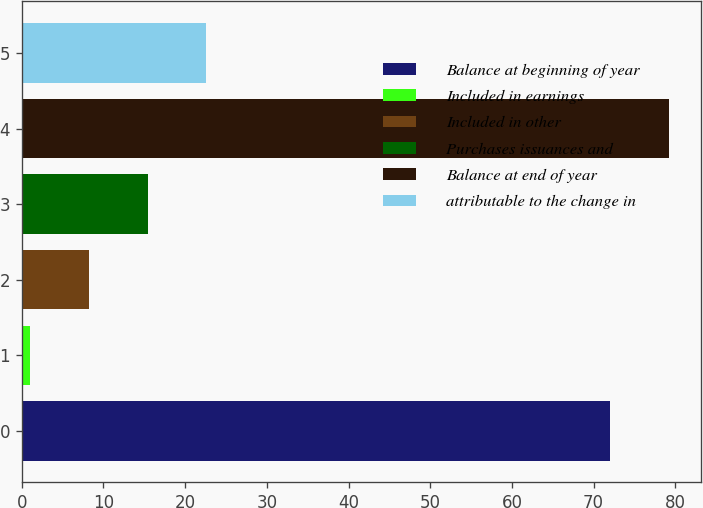Convert chart. <chart><loc_0><loc_0><loc_500><loc_500><bar_chart><fcel>Balance at beginning of year<fcel>Included in earnings<fcel>Included in other<fcel>Purchases issuances and<fcel>Balance at end of year<fcel>attributable to the change in<nl><fcel>72<fcel>1<fcel>8.2<fcel>15.4<fcel>79.2<fcel>22.6<nl></chart> 